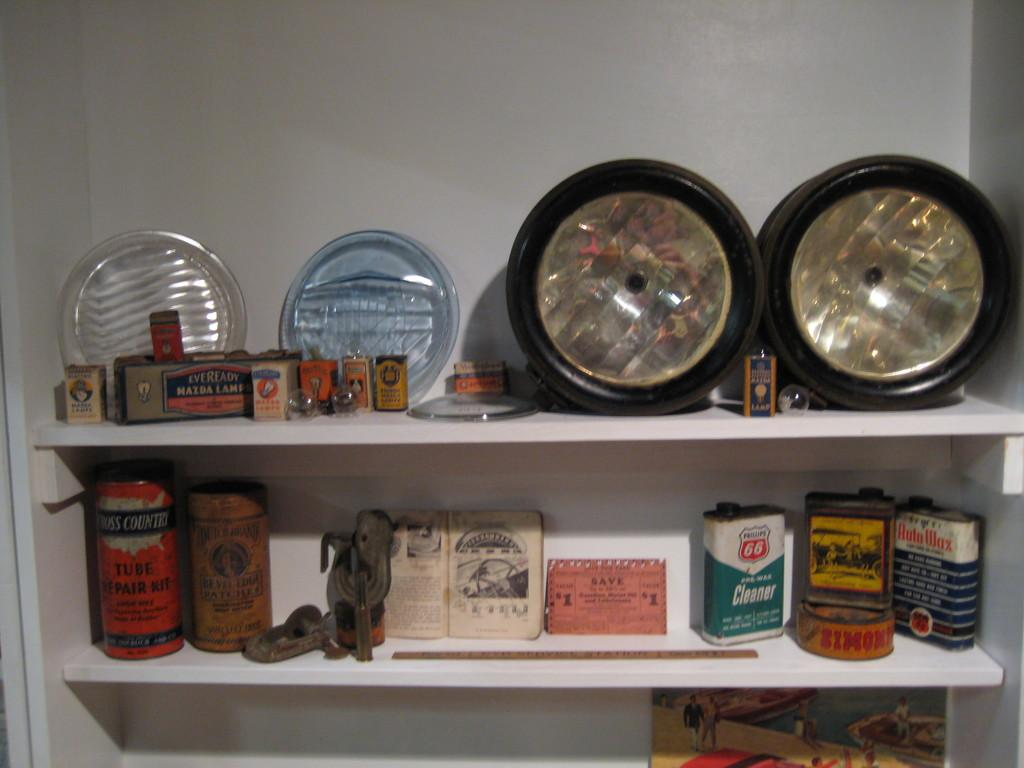Provide a one-sentence caption for the provided image. Two white shelves with auto supplies on it and one of the containers says Auto Wax in red letters with a white background. 